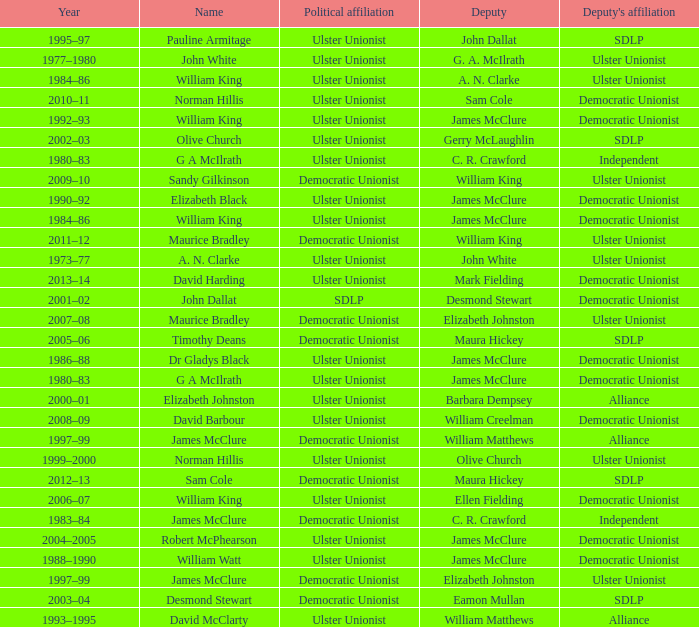What is the name of the deputy in 1992–93? James McClure. 